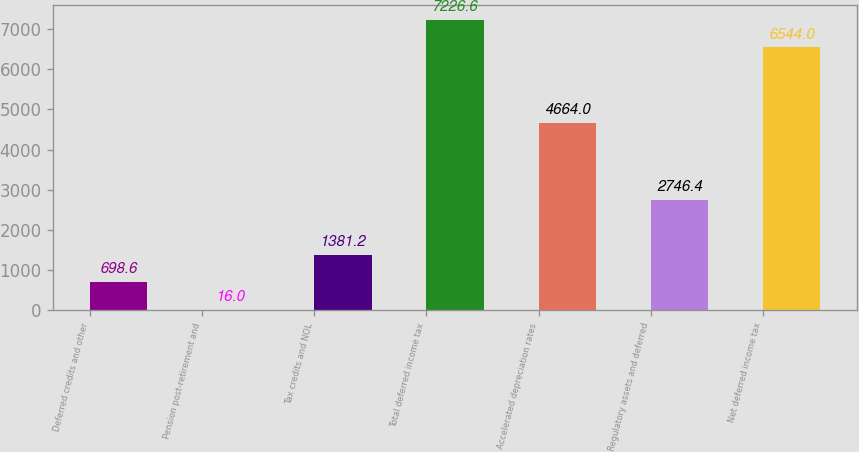Convert chart to OTSL. <chart><loc_0><loc_0><loc_500><loc_500><bar_chart><fcel>Deferred credits and other<fcel>Pension post-retirement and<fcel>Tax credits and NOL<fcel>Total deferred income tax<fcel>Accelerated depreciation rates<fcel>Regulatory assets and deferred<fcel>Net deferred income tax<nl><fcel>698.6<fcel>16<fcel>1381.2<fcel>7226.6<fcel>4664<fcel>2746.4<fcel>6544<nl></chart> 